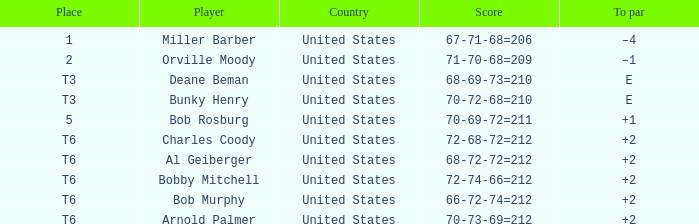What is the score of player bob rosburg? 70-69-72=211. 